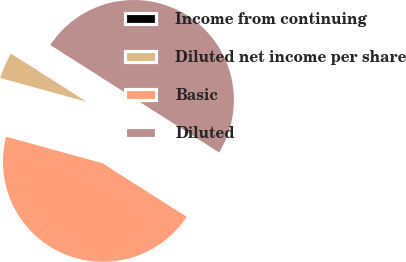Convert chart. <chart><loc_0><loc_0><loc_500><loc_500><pie_chart><fcel>Income from continuing<fcel>Diluted net income per share<fcel>Basic<fcel>Diluted<nl><fcel>0.0%<fcel>4.75%<fcel>45.25%<fcel>50.0%<nl></chart> 